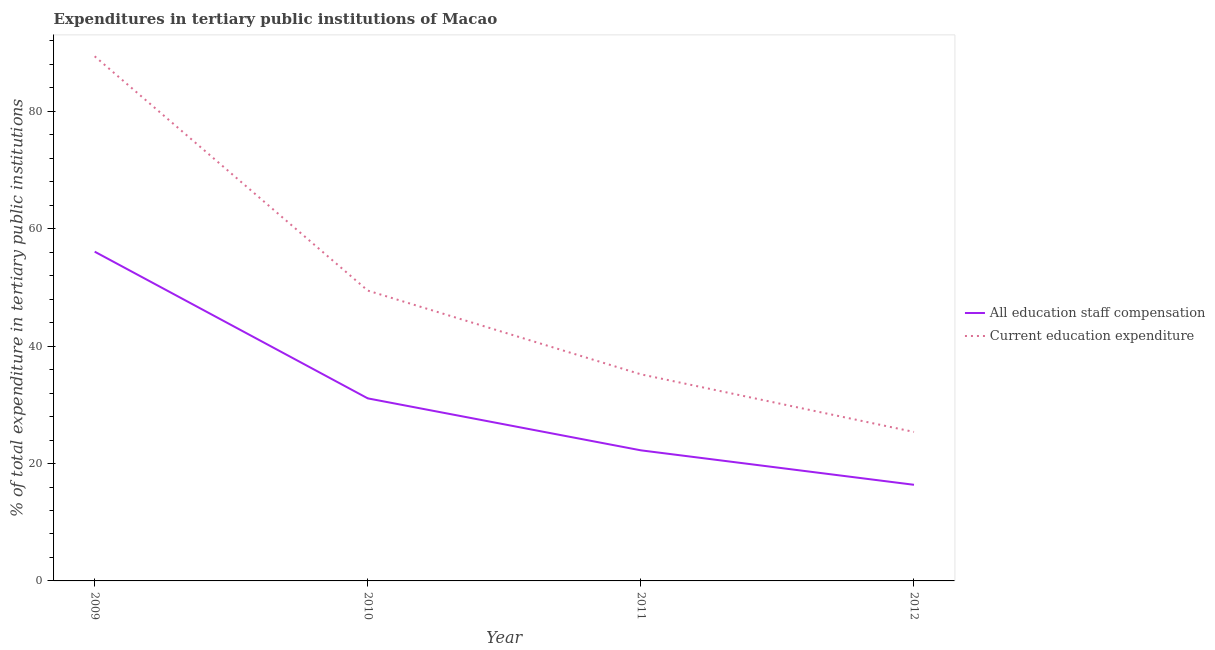How many different coloured lines are there?
Ensure brevity in your answer.  2. Does the line corresponding to expenditure in staff compensation intersect with the line corresponding to expenditure in education?
Offer a very short reply. No. Is the number of lines equal to the number of legend labels?
Provide a short and direct response. Yes. What is the expenditure in staff compensation in 2011?
Your response must be concise. 22.25. Across all years, what is the maximum expenditure in education?
Your response must be concise. 89.39. Across all years, what is the minimum expenditure in staff compensation?
Ensure brevity in your answer.  16.38. What is the total expenditure in staff compensation in the graph?
Your answer should be very brief. 125.84. What is the difference between the expenditure in staff compensation in 2009 and that in 2011?
Provide a succinct answer. 33.85. What is the difference between the expenditure in education in 2012 and the expenditure in staff compensation in 2009?
Keep it short and to the point. -30.72. What is the average expenditure in staff compensation per year?
Make the answer very short. 31.46. In the year 2011, what is the difference between the expenditure in education and expenditure in staff compensation?
Provide a short and direct response. 12.95. What is the ratio of the expenditure in education in 2010 to that in 2011?
Your answer should be compact. 1.41. Is the expenditure in education in 2009 less than that in 2010?
Offer a terse response. No. What is the difference between the highest and the second highest expenditure in education?
Provide a short and direct response. 39.92. What is the difference between the highest and the lowest expenditure in staff compensation?
Your response must be concise. 39.72. In how many years, is the expenditure in staff compensation greater than the average expenditure in staff compensation taken over all years?
Provide a short and direct response. 1. Is the sum of the expenditure in education in 2010 and 2011 greater than the maximum expenditure in staff compensation across all years?
Provide a succinct answer. Yes. Is the expenditure in education strictly greater than the expenditure in staff compensation over the years?
Give a very brief answer. Yes. How many lines are there?
Make the answer very short. 2. Where does the legend appear in the graph?
Your answer should be compact. Center right. How are the legend labels stacked?
Provide a succinct answer. Vertical. What is the title of the graph?
Your answer should be very brief. Expenditures in tertiary public institutions of Macao. What is the label or title of the Y-axis?
Provide a short and direct response. % of total expenditure in tertiary public institutions. What is the % of total expenditure in tertiary public institutions in All education staff compensation in 2009?
Your response must be concise. 56.1. What is the % of total expenditure in tertiary public institutions of Current education expenditure in 2009?
Ensure brevity in your answer.  89.39. What is the % of total expenditure in tertiary public institutions of All education staff compensation in 2010?
Provide a short and direct response. 31.1. What is the % of total expenditure in tertiary public institutions in Current education expenditure in 2010?
Provide a short and direct response. 49.47. What is the % of total expenditure in tertiary public institutions of All education staff compensation in 2011?
Give a very brief answer. 22.25. What is the % of total expenditure in tertiary public institutions of Current education expenditure in 2011?
Make the answer very short. 35.2. What is the % of total expenditure in tertiary public institutions in All education staff compensation in 2012?
Provide a succinct answer. 16.38. What is the % of total expenditure in tertiary public institutions in Current education expenditure in 2012?
Provide a succinct answer. 25.39. Across all years, what is the maximum % of total expenditure in tertiary public institutions of All education staff compensation?
Your answer should be compact. 56.1. Across all years, what is the maximum % of total expenditure in tertiary public institutions in Current education expenditure?
Your answer should be very brief. 89.39. Across all years, what is the minimum % of total expenditure in tertiary public institutions in All education staff compensation?
Your answer should be very brief. 16.38. Across all years, what is the minimum % of total expenditure in tertiary public institutions of Current education expenditure?
Offer a very short reply. 25.39. What is the total % of total expenditure in tertiary public institutions of All education staff compensation in the graph?
Provide a succinct answer. 125.84. What is the total % of total expenditure in tertiary public institutions in Current education expenditure in the graph?
Offer a terse response. 199.45. What is the difference between the % of total expenditure in tertiary public institutions in All education staff compensation in 2009 and that in 2010?
Your answer should be compact. 25. What is the difference between the % of total expenditure in tertiary public institutions of Current education expenditure in 2009 and that in 2010?
Your answer should be very brief. 39.92. What is the difference between the % of total expenditure in tertiary public institutions of All education staff compensation in 2009 and that in 2011?
Give a very brief answer. 33.85. What is the difference between the % of total expenditure in tertiary public institutions of Current education expenditure in 2009 and that in 2011?
Offer a terse response. 54.19. What is the difference between the % of total expenditure in tertiary public institutions of All education staff compensation in 2009 and that in 2012?
Give a very brief answer. 39.72. What is the difference between the % of total expenditure in tertiary public institutions in Current education expenditure in 2009 and that in 2012?
Your answer should be compact. 64.01. What is the difference between the % of total expenditure in tertiary public institutions in All education staff compensation in 2010 and that in 2011?
Keep it short and to the point. 8.85. What is the difference between the % of total expenditure in tertiary public institutions in Current education expenditure in 2010 and that in 2011?
Provide a short and direct response. 14.27. What is the difference between the % of total expenditure in tertiary public institutions in All education staff compensation in 2010 and that in 2012?
Your answer should be compact. 14.72. What is the difference between the % of total expenditure in tertiary public institutions of Current education expenditure in 2010 and that in 2012?
Offer a very short reply. 24.08. What is the difference between the % of total expenditure in tertiary public institutions in All education staff compensation in 2011 and that in 2012?
Your answer should be compact. 5.87. What is the difference between the % of total expenditure in tertiary public institutions in Current education expenditure in 2011 and that in 2012?
Make the answer very short. 9.82. What is the difference between the % of total expenditure in tertiary public institutions in All education staff compensation in 2009 and the % of total expenditure in tertiary public institutions in Current education expenditure in 2010?
Give a very brief answer. 6.64. What is the difference between the % of total expenditure in tertiary public institutions of All education staff compensation in 2009 and the % of total expenditure in tertiary public institutions of Current education expenditure in 2011?
Your response must be concise. 20.9. What is the difference between the % of total expenditure in tertiary public institutions in All education staff compensation in 2009 and the % of total expenditure in tertiary public institutions in Current education expenditure in 2012?
Your answer should be compact. 30.72. What is the difference between the % of total expenditure in tertiary public institutions in All education staff compensation in 2010 and the % of total expenditure in tertiary public institutions in Current education expenditure in 2011?
Your answer should be very brief. -4.1. What is the difference between the % of total expenditure in tertiary public institutions of All education staff compensation in 2010 and the % of total expenditure in tertiary public institutions of Current education expenditure in 2012?
Offer a very short reply. 5.72. What is the difference between the % of total expenditure in tertiary public institutions in All education staff compensation in 2011 and the % of total expenditure in tertiary public institutions in Current education expenditure in 2012?
Your answer should be compact. -3.13. What is the average % of total expenditure in tertiary public institutions in All education staff compensation per year?
Your answer should be very brief. 31.46. What is the average % of total expenditure in tertiary public institutions in Current education expenditure per year?
Your response must be concise. 49.86. In the year 2009, what is the difference between the % of total expenditure in tertiary public institutions in All education staff compensation and % of total expenditure in tertiary public institutions in Current education expenditure?
Your answer should be very brief. -33.29. In the year 2010, what is the difference between the % of total expenditure in tertiary public institutions of All education staff compensation and % of total expenditure in tertiary public institutions of Current education expenditure?
Give a very brief answer. -18.36. In the year 2011, what is the difference between the % of total expenditure in tertiary public institutions in All education staff compensation and % of total expenditure in tertiary public institutions in Current education expenditure?
Offer a very short reply. -12.95. In the year 2012, what is the difference between the % of total expenditure in tertiary public institutions of All education staff compensation and % of total expenditure in tertiary public institutions of Current education expenditure?
Your answer should be very brief. -9. What is the ratio of the % of total expenditure in tertiary public institutions of All education staff compensation in 2009 to that in 2010?
Offer a very short reply. 1.8. What is the ratio of the % of total expenditure in tertiary public institutions in Current education expenditure in 2009 to that in 2010?
Provide a short and direct response. 1.81. What is the ratio of the % of total expenditure in tertiary public institutions of All education staff compensation in 2009 to that in 2011?
Your answer should be compact. 2.52. What is the ratio of the % of total expenditure in tertiary public institutions of Current education expenditure in 2009 to that in 2011?
Give a very brief answer. 2.54. What is the ratio of the % of total expenditure in tertiary public institutions of All education staff compensation in 2009 to that in 2012?
Provide a succinct answer. 3.42. What is the ratio of the % of total expenditure in tertiary public institutions in Current education expenditure in 2009 to that in 2012?
Offer a terse response. 3.52. What is the ratio of the % of total expenditure in tertiary public institutions of All education staff compensation in 2010 to that in 2011?
Your response must be concise. 1.4. What is the ratio of the % of total expenditure in tertiary public institutions of Current education expenditure in 2010 to that in 2011?
Provide a succinct answer. 1.41. What is the ratio of the % of total expenditure in tertiary public institutions in All education staff compensation in 2010 to that in 2012?
Offer a terse response. 1.9. What is the ratio of the % of total expenditure in tertiary public institutions of Current education expenditure in 2010 to that in 2012?
Your answer should be very brief. 1.95. What is the ratio of the % of total expenditure in tertiary public institutions of All education staff compensation in 2011 to that in 2012?
Ensure brevity in your answer.  1.36. What is the ratio of the % of total expenditure in tertiary public institutions of Current education expenditure in 2011 to that in 2012?
Offer a very short reply. 1.39. What is the difference between the highest and the second highest % of total expenditure in tertiary public institutions of All education staff compensation?
Your answer should be very brief. 25. What is the difference between the highest and the second highest % of total expenditure in tertiary public institutions in Current education expenditure?
Make the answer very short. 39.92. What is the difference between the highest and the lowest % of total expenditure in tertiary public institutions of All education staff compensation?
Your response must be concise. 39.72. What is the difference between the highest and the lowest % of total expenditure in tertiary public institutions in Current education expenditure?
Offer a terse response. 64.01. 